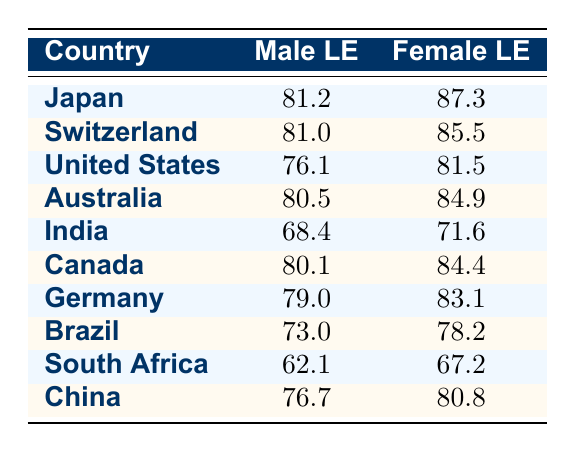What is the life expectancy for males in Japan? The table shows that the male life expectancy in Japan is 81.2 years.
Answer: 81.2 What is the difference in life expectancy between males and females in Germany? For Germany, the male life expectancy is 79.0 years and the female life expectancy is 83.1 years. The difference is calculated as 83.1 - 79.0 = 4.1 years.
Answer: 4.1 Is the life expectancy for males in the United States higher than that in India? The male life expectancy in the United States is 76.1 years and in India, it is 68.4 years. Since 76.1 is greater than 68.4, the statement is true.
Answer: Yes What is the average female life expectancy across all listed countries? To find the average, sum the female life expectancies: (87.3 + 85.5 + 81.5 + 84.9 + 71.6 + 84.4 + 83.1 + 78.2 + 67.2 + 80.8) = 837.6, then divide by the number of countries (10): 837.6 / 10 = 83.76 years.
Answer: 83.76 Is the life expectancy for females in Canada lower than in China? The female life expectancy in Canada is 84.4 years, and in China, it is 80.8 years. Since 84.4 is greater than 80.8, the statement is false.
Answer: No What country has the highest female life expectancy and what is the value? Upon reviewing the table, Japan has the highest female life expectancy at 87.3 years.
Answer: Japan, 87.3 What is the difference in life expectancy between males in South Africa and females in Australia? The male life expectancy in South Africa is 62.1 years, and the female life expectancy in Australia is 84.9 years. The difference is calculated as 84.9 - 62.1 = 22.8 years.
Answer: 22.8 Which country has the lowest male life expectancy? Among the listed countries, South Africa has the lowest male life expectancy at 62.1 years.
Answer: South Africa, 62.1 